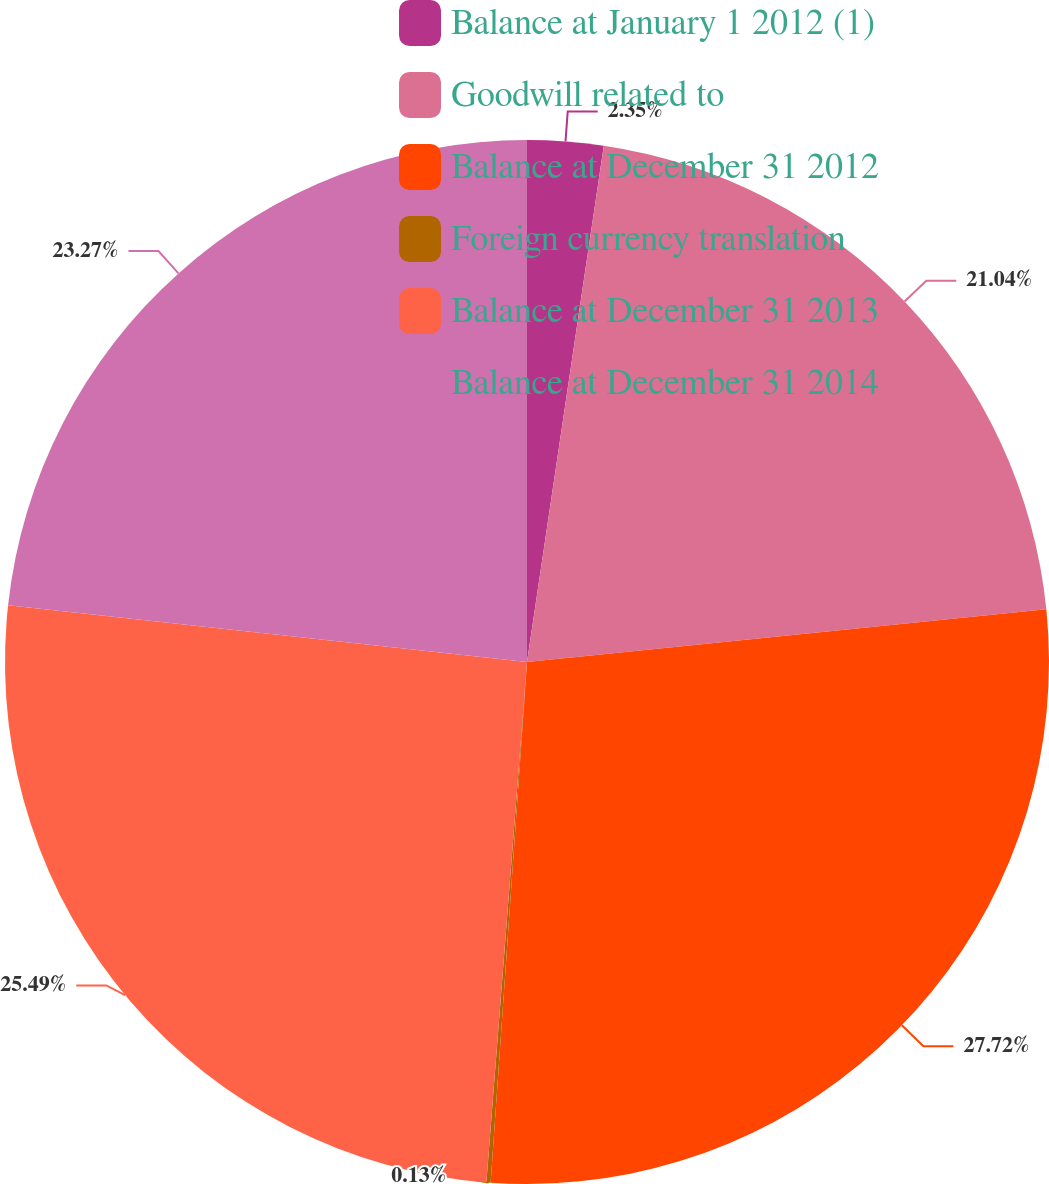Convert chart. <chart><loc_0><loc_0><loc_500><loc_500><pie_chart><fcel>Balance at January 1 2012 (1)<fcel>Goodwill related to<fcel>Balance at December 31 2012<fcel>Foreign currency translation<fcel>Balance at December 31 2013<fcel>Balance at December 31 2014<nl><fcel>2.35%<fcel>21.04%<fcel>27.72%<fcel>0.13%<fcel>25.49%<fcel>23.27%<nl></chart> 